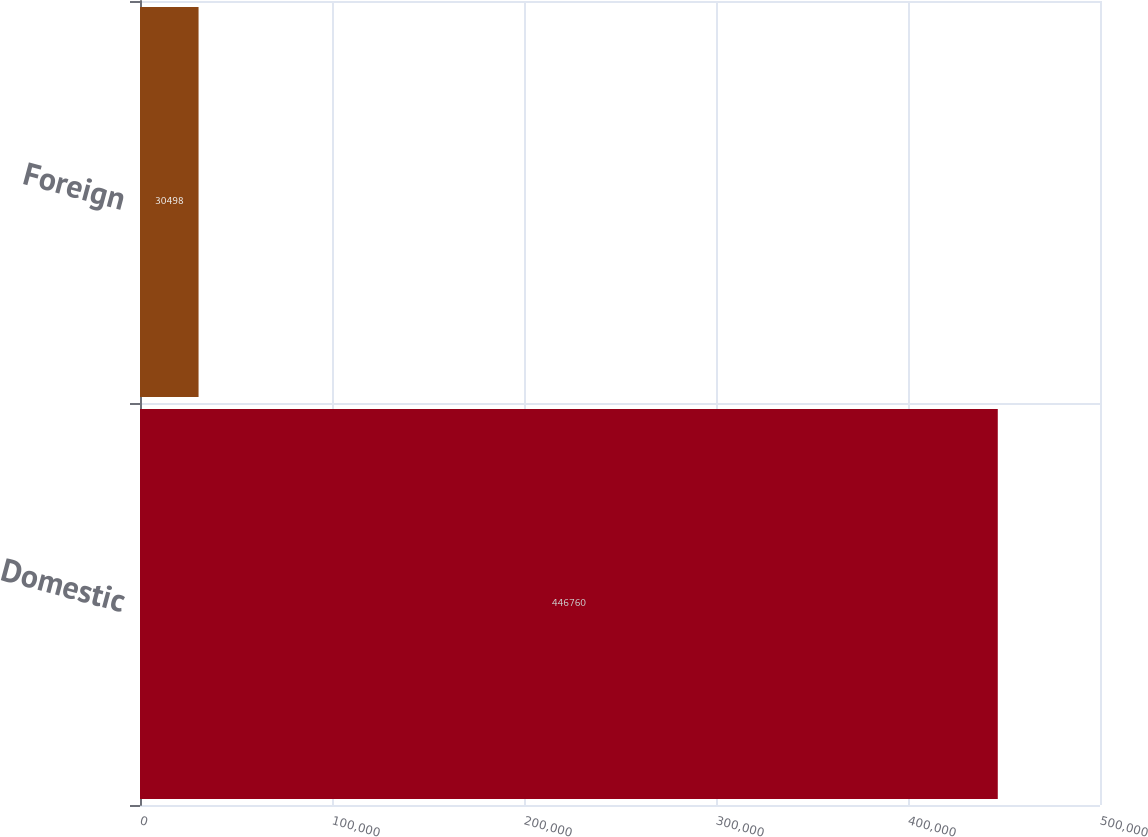Convert chart. <chart><loc_0><loc_0><loc_500><loc_500><bar_chart><fcel>Domestic<fcel>Foreign<nl><fcel>446760<fcel>30498<nl></chart> 